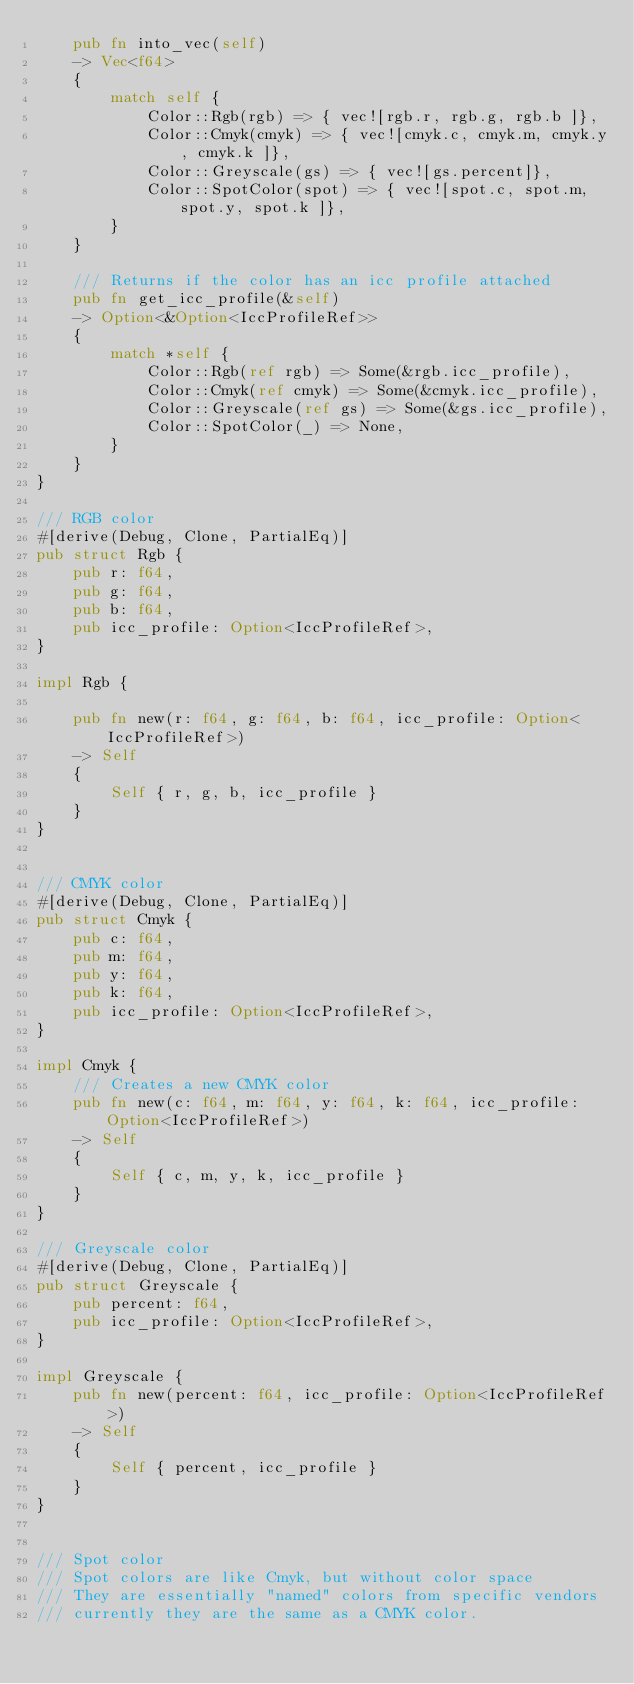Convert code to text. <code><loc_0><loc_0><loc_500><loc_500><_Rust_>    pub fn into_vec(self)
    -> Vec<f64>
    {
        match self {
            Color::Rgb(rgb) => { vec![rgb.r, rgb.g, rgb.b ]},
            Color::Cmyk(cmyk) => { vec![cmyk.c, cmyk.m, cmyk.y, cmyk.k ]},
            Color::Greyscale(gs) => { vec![gs.percent]},
            Color::SpotColor(spot) => { vec![spot.c, spot.m, spot.y, spot.k ]},
        }
    }

    /// Returns if the color has an icc profile attached
    pub fn get_icc_profile(&self)
    -> Option<&Option<IccProfileRef>>
    {
        match *self {
            Color::Rgb(ref rgb) => Some(&rgb.icc_profile),
            Color::Cmyk(ref cmyk) => Some(&cmyk.icc_profile),
            Color::Greyscale(ref gs) => Some(&gs.icc_profile),
            Color::SpotColor(_) => None,
        }
    }
}

/// RGB color
#[derive(Debug, Clone, PartialEq)]
pub struct Rgb {
    pub r: f64,
    pub g: f64,
    pub b: f64,
    pub icc_profile: Option<IccProfileRef>,
}

impl Rgb {

    pub fn new(r: f64, g: f64, b: f64, icc_profile: Option<IccProfileRef>)
    -> Self
    {
        Self { r, g, b, icc_profile }
    }
}


/// CMYK color
#[derive(Debug, Clone, PartialEq)]
pub struct Cmyk {
    pub c: f64,
    pub m: f64,
    pub y: f64,
    pub k: f64,
    pub icc_profile: Option<IccProfileRef>,
}

impl Cmyk {
    /// Creates a new CMYK color
    pub fn new(c: f64, m: f64, y: f64, k: f64, icc_profile: Option<IccProfileRef>)
    -> Self
    {
        Self { c, m, y, k, icc_profile }
    }
}

/// Greyscale color
#[derive(Debug, Clone, PartialEq)]
pub struct Greyscale {
    pub percent: f64,
    pub icc_profile: Option<IccProfileRef>,
}

impl Greyscale {
    pub fn new(percent: f64, icc_profile: Option<IccProfileRef>)
    -> Self
    {
        Self { percent, icc_profile }
    }
}


/// Spot color
/// Spot colors are like Cmyk, but without color space
/// They are essentially "named" colors from specific vendors
/// currently they are the same as a CMYK color.</code> 